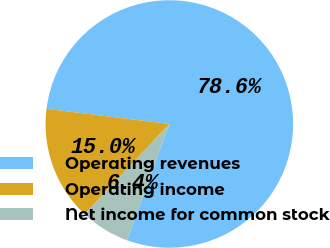Convert chart. <chart><loc_0><loc_0><loc_500><loc_500><pie_chart><fcel>Operating revenues<fcel>Operating income<fcel>Net income for common stock<nl><fcel>78.6%<fcel>14.97%<fcel>6.44%<nl></chart> 